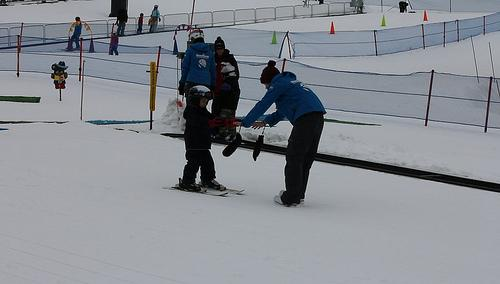Mention the key objects and colors found in the picture. Orange and green cones, black hat with tassel, blue jacket with white logo, child with red and black gloves, and a temporary fence set up on the snow. What activity is taking place in the picture, and who is involved? Children and adults are skiing on a slope with safety cones, fences, and various ski gear like gloves and helmets. Describe the scene of the image in a single sentence. A children's ski slope filled with adults helping little skiers, safety cones, fences, and various ski accessories. Explain what kind of weather or environment is depicted in the picture. A snowy environment perfect for skiing, with safety measures like cones and fences in place. Provide a brief description of the most prominent scene in the image. A small child on skis is being assisted by an adult, as they navigate a children's ski slope surrounded by safety cones and temporary fencing. Summarize the main objects and activities visible in the image. A ski slope with children and adults skiing, safety cones and fences, ski gear like helmets and gloves, and signage. Write a brief description of the actions taking place in the picture. Children and adults are skiing on a snowy slope, surrounded by temporary fences, safety cones, and ski accessories. Mention a few details about the people in the image, and what they are doing. A small child on skis with a helmet, an adult helping the child, and people wearing ski gear like gloves, jackets, and hats while skiing. Describe the mood or atmosphere of the image. A fun and festive atmosphere on a snowy ski slope, with children and adults actively participating in skiing activities. List the major elements in the image and their placements. Child on skis (center), adult helper (center-right), orange and green safety cones (left and right), temporary fencing (back), sign with cartoon animal (top-left), mesh fence (top-right). 